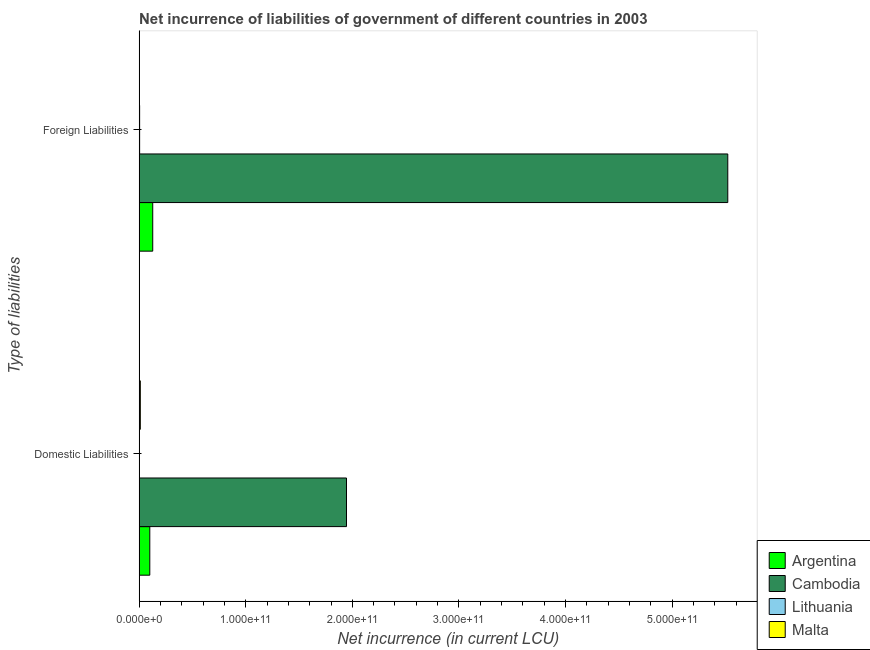Are the number of bars per tick equal to the number of legend labels?
Your response must be concise. No. Are the number of bars on each tick of the Y-axis equal?
Offer a terse response. No. What is the label of the 1st group of bars from the top?
Ensure brevity in your answer.  Foreign Liabilities. What is the net incurrence of foreign liabilities in Lithuania?
Your answer should be compact. 4.94e+08. Across all countries, what is the maximum net incurrence of domestic liabilities?
Your answer should be very brief. 1.95e+11. Across all countries, what is the minimum net incurrence of domestic liabilities?
Keep it short and to the point. 0. In which country was the net incurrence of domestic liabilities maximum?
Your response must be concise. Cambodia. What is the total net incurrence of domestic liabilities in the graph?
Make the answer very short. 2.06e+11. What is the difference between the net incurrence of foreign liabilities in Cambodia and that in Lithuania?
Make the answer very short. 5.52e+11. What is the difference between the net incurrence of foreign liabilities in Malta and the net incurrence of domestic liabilities in Argentina?
Ensure brevity in your answer.  -9.94e+09. What is the average net incurrence of foreign liabilities per country?
Offer a very short reply. 1.41e+11. What is the difference between the net incurrence of foreign liabilities and net incurrence of domestic liabilities in Cambodia?
Your answer should be compact. 3.58e+11. What is the ratio of the net incurrence of foreign liabilities in Lithuania to that in Cambodia?
Your answer should be very brief. 0. In how many countries, is the net incurrence of domestic liabilities greater than the average net incurrence of domestic liabilities taken over all countries?
Provide a short and direct response. 1. How many countries are there in the graph?
Your answer should be compact. 4. What is the difference between two consecutive major ticks on the X-axis?
Keep it short and to the point. 1.00e+11. Are the values on the major ticks of X-axis written in scientific E-notation?
Keep it short and to the point. Yes. Does the graph contain grids?
Keep it short and to the point. No. What is the title of the graph?
Make the answer very short. Net incurrence of liabilities of government of different countries in 2003. Does "United Kingdom" appear as one of the legend labels in the graph?
Your answer should be very brief. No. What is the label or title of the X-axis?
Ensure brevity in your answer.  Net incurrence (in current LCU). What is the label or title of the Y-axis?
Your response must be concise. Type of liabilities. What is the Net incurrence (in current LCU) in Argentina in Domestic Liabilities?
Provide a succinct answer. 1.00e+1. What is the Net incurrence (in current LCU) of Cambodia in Domestic Liabilities?
Provide a short and direct response. 1.95e+11. What is the Net incurrence (in current LCU) of Malta in Domestic Liabilities?
Make the answer very short. 1.15e+09. What is the Net incurrence (in current LCU) in Argentina in Foreign Liabilities?
Offer a very short reply. 1.28e+1. What is the Net incurrence (in current LCU) of Cambodia in Foreign Liabilities?
Make the answer very short. 5.52e+11. What is the Net incurrence (in current LCU) of Lithuania in Foreign Liabilities?
Keep it short and to the point. 4.94e+08. What is the Net incurrence (in current LCU) in Malta in Foreign Liabilities?
Ensure brevity in your answer.  9.51e+07. Across all Type of liabilities, what is the maximum Net incurrence (in current LCU) in Argentina?
Ensure brevity in your answer.  1.28e+1. Across all Type of liabilities, what is the maximum Net incurrence (in current LCU) in Cambodia?
Keep it short and to the point. 5.52e+11. Across all Type of liabilities, what is the maximum Net incurrence (in current LCU) in Lithuania?
Offer a very short reply. 4.94e+08. Across all Type of liabilities, what is the maximum Net incurrence (in current LCU) in Malta?
Give a very brief answer. 1.15e+09. Across all Type of liabilities, what is the minimum Net incurrence (in current LCU) of Argentina?
Keep it short and to the point. 1.00e+1. Across all Type of liabilities, what is the minimum Net incurrence (in current LCU) in Cambodia?
Keep it short and to the point. 1.95e+11. Across all Type of liabilities, what is the minimum Net incurrence (in current LCU) of Lithuania?
Ensure brevity in your answer.  0. Across all Type of liabilities, what is the minimum Net incurrence (in current LCU) of Malta?
Your answer should be very brief. 9.51e+07. What is the total Net incurrence (in current LCU) of Argentina in the graph?
Offer a terse response. 2.28e+1. What is the total Net incurrence (in current LCU) of Cambodia in the graph?
Your response must be concise. 7.47e+11. What is the total Net incurrence (in current LCU) in Lithuania in the graph?
Offer a terse response. 4.94e+08. What is the total Net incurrence (in current LCU) of Malta in the graph?
Your answer should be compact. 1.25e+09. What is the difference between the Net incurrence (in current LCU) of Argentina in Domestic Liabilities and that in Foreign Liabilities?
Give a very brief answer. -2.76e+09. What is the difference between the Net incurrence (in current LCU) of Cambodia in Domestic Liabilities and that in Foreign Liabilities?
Your answer should be very brief. -3.58e+11. What is the difference between the Net incurrence (in current LCU) in Malta in Domestic Liabilities and that in Foreign Liabilities?
Keep it short and to the point. 1.06e+09. What is the difference between the Net incurrence (in current LCU) in Argentina in Domestic Liabilities and the Net incurrence (in current LCU) in Cambodia in Foreign Liabilities?
Give a very brief answer. -5.42e+11. What is the difference between the Net incurrence (in current LCU) of Argentina in Domestic Liabilities and the Net incurrence (in current LCU) of Lithuania in Foreign Liabilities?
Give a very brief answer. 9.54e+09. What is the difference between the Net incurrence (in current LCU) in Argentina in Domestic Liabilities and the Net incurrence (in current LCU) in Malta in Foreign Liabilities?
Offer a very short reply. 9.94e+09. What is the difference between the Net incurrence (in current LCU) in Cambodia in Domestic Liabilities and the Net incurrence (in current LCU) in Lithuania in Foreign Liabilities?
Ensure brevity in your answer.  1.94e+11. What is the difference between the Net incurrence (in current LCU) of Cambodia in Domestic Liabilities and the Net incurrence (in current LCU) of Malta in Foreign Liabilities?
Provide a succinct answer. 1.94e+11. What is the average Net incurrence (in current LCU) in Argentina per Type of liabilities?
Provide a succinct answer. 1.14e+1. What is the average Net incurrence (in current LCU) of Cambodia per Type of liabilities?
Make the answer very short. 3.73e+11. What is the average Net incurrence (in current LCU) in Lithuania per Type of liabilities?
Your answer should be very brief. 2.47e+08. What is the average Net incurrence (in current LCU) in Malta per Type of liabilities?
Make the answer very short. 6.23e+08. What is the difference between the Net incurrence (in current LCU) of Argentina and Net incurrence (in current LCU) of Cambodia in Domestic Liabilities?
Offer a very short reply. -1.84e+11. What is the difference between the Net incurrence (in current LCU) in Argentina and Net incurrence (in current LCU) in Malta in Domestic Liabilities?
Keep it short and to the point. 8.88e+09. What is the difference between the Net incurrence (in current LCU) in Cambodia and Net incurrence (in current LCU) in Malta in Domestic Liabilities?
Make the answer very short. 1.93e+11. What is the difference between the Net incurrence (in current LCU) in Argentina and Net incurrence (in current LCU) in Cambodia in Foreign Liabilities?
Your response must be concise. -5.39e+11. What is the difference between the Net incurrence (in current LCU) of Argentina and Net incurrence (in current LCU) of Lithuania in Foreign Liabilities?
Offer a very short reply. 1.23e+1. What is the difference between the Net incurrence (in current LCU) of Argentina and Net incurrence (in current LCU) of Malta in Foreign Liabilities?
Offer a very short reply. 1.27e+1. What is the difference between the Net incurrence (in current LCU) in Cambodia and Net incurrence (in current LCU) in Lithuania in Foreign Liabilities?
Keep it short and to the point. 5.52e+11. What is the difference between the Net incurrence (in current LCU) of Cambodia and Net incurrence (in current LCU) of Malta in Foreign Liabilities?
Provide a succinct answer. 5.52e+11. What is the difference between the Net incurrence (in current LCU) in Lithuania and Net incurrence (in current LCU) in Malta in Foreign Liabilities?
Your response must be concise. 3.98e+08. What is the ratio of the Net incurrence (in current LCU) of Argentina in Domestic Liabilities to that in Foreign Liabilities?
Ensure brevity in your answer.  0.78. What is the ratio of the Net incurrence (in current LCU) of Cambodia in Domestic Liabilities to that in Foreign Liabilities?
Provide a short and direct response. 0.35. What is the ratio of the Net incurrence (in current LCU) of Malta in Domestic Liabilities to that in Foreign Liabilities?
Provide a succinct answer. 12.1. What is the difference between the highest and the second highest Net incurrence (in current LCU) of Argentina?
Your answer should be compact. 2.76e+09. What is the difference between the highest and the second highest Net incurrence (in current LCU) of Cambodia?
Ensure brevity in your answer.  3.58e+11. What is the difference between the highest and the second highest Net incurrence (in current LCU) in Malta?
Offer a terse response. 1.06e+09. What is the difference between the highest and the lowest Net incurrence (in current LCU) of Argentina?
Provide a short and direct response. 2.76e+09. What is the difference between the highest and the lowest Net incurrence (in current LCU) in Cambodia?
Offer a very short reply. 3.58e+11. What is the difference between the highest and the lowest Net incurrence (in current LCU) of Lithuania?
Give a very brief answer. 4.94e+08. What is the difference between the highest and the lowest Net incurrence (in current LCU) of Malta?
Offer a terse response. 1.06e+09. 